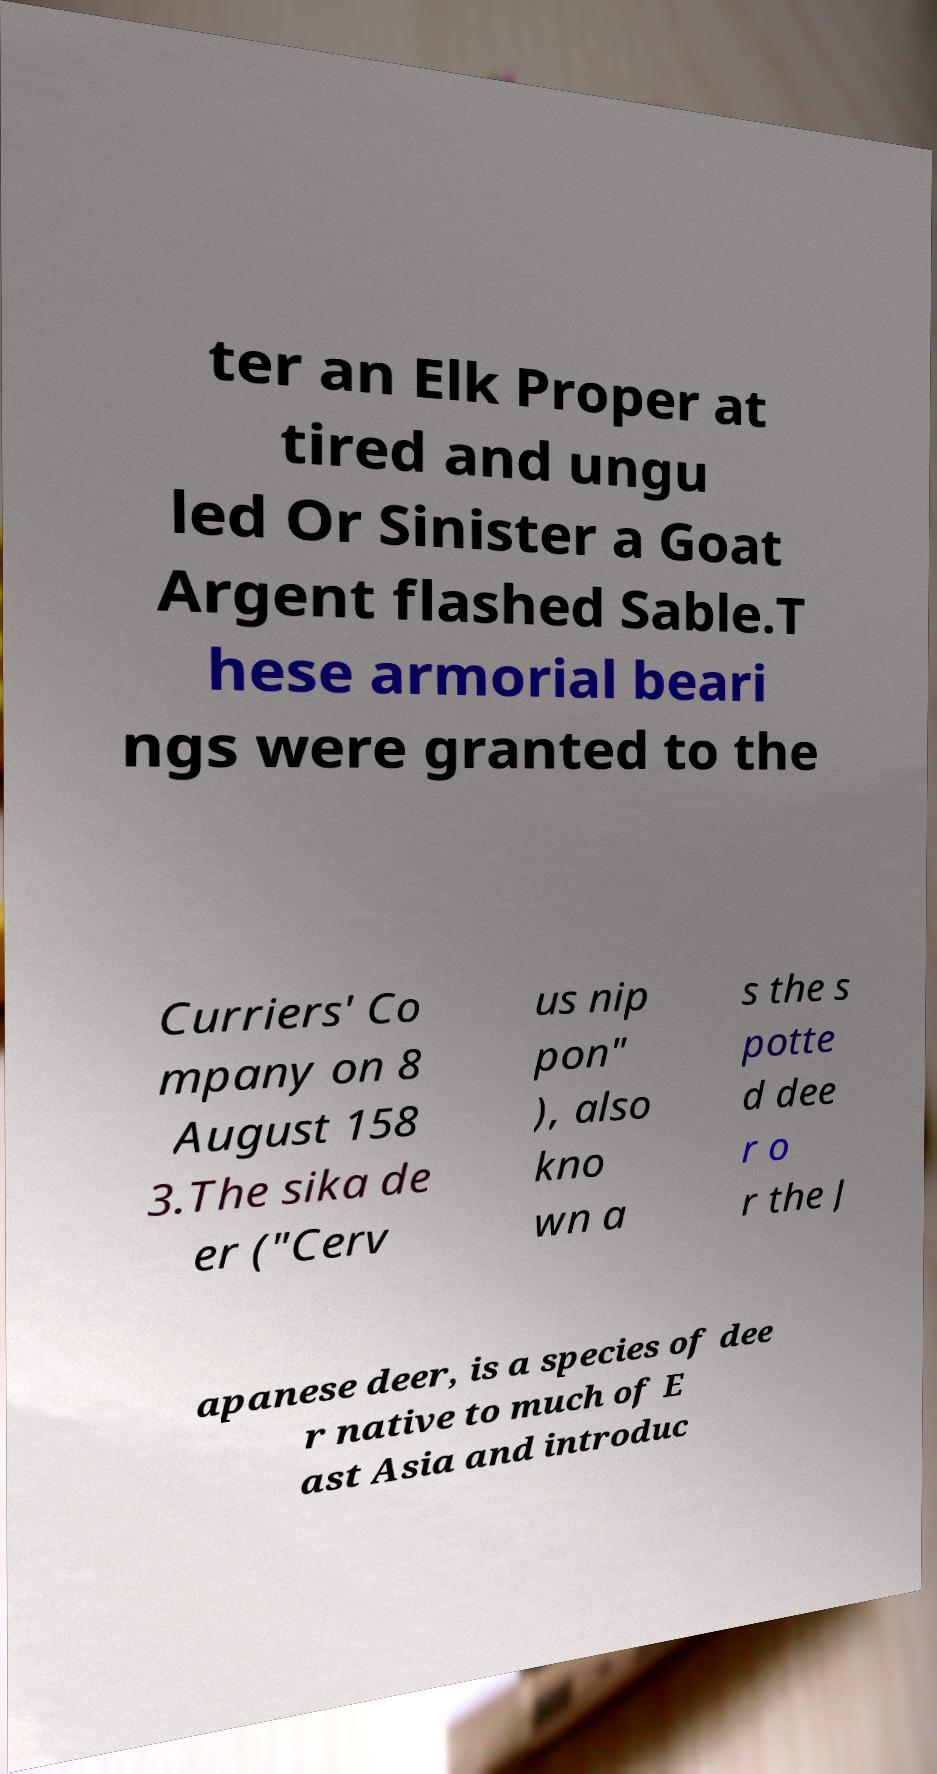I need the written content from this picture converted into text. Can you do that? ter an Elk Proper at tired and ungu led Or Sinister a Goat Argent flashed Sable.T hese armorial beari ngs were granted to the Curriers' Co mpany on 8 August 158 3.The sika de er ("Cerv us nip pon" ), also kno wn a s the s potte d dee r o r the J apanese deer, is a species of dee r native to much of E ast Asia and introduc 